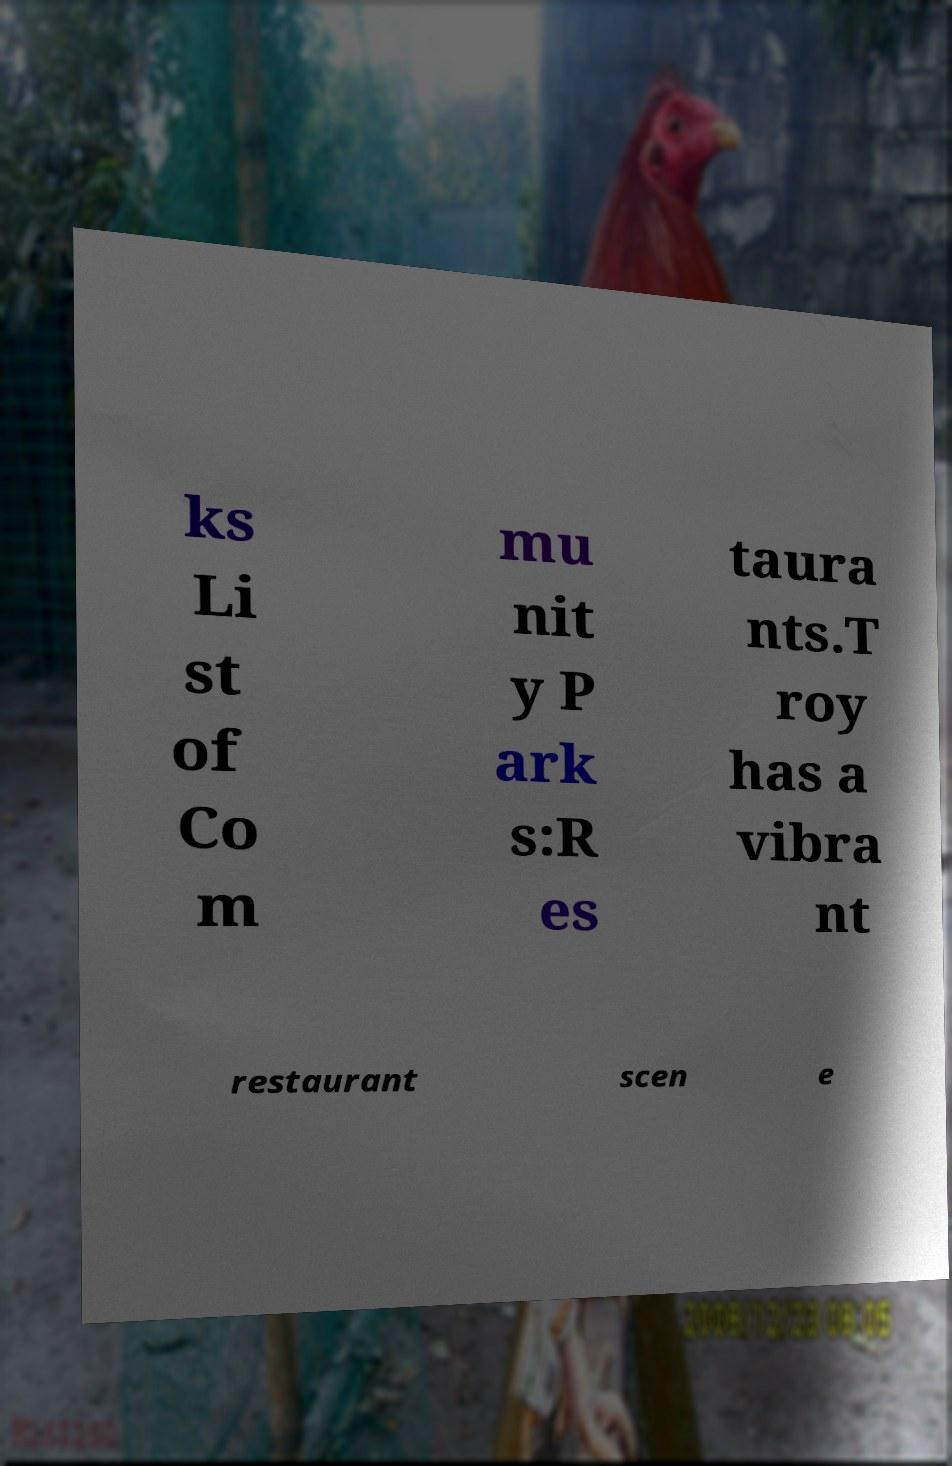I need the written content from this picture converted into text. Can you do that? ks Li st of Co m mu nit y P ark s:R es taura nts.T roy has a vibra nt restaurant scen e 